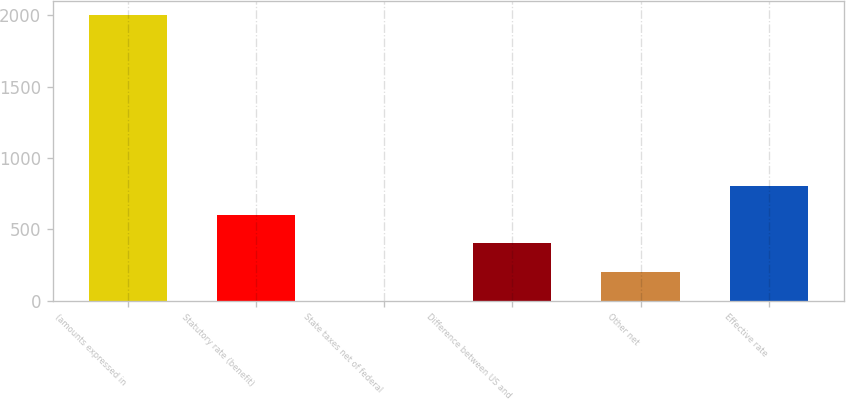Convert chart. <chart><loc_0><loc_0><loc_500><loc_500><bar_chart><fcel>(amounts expressed in<fcel>Statutory rate (benefit)<fcel>State taxes net of federal<fcel>Difference between US and<fcel>Other net<fcel>Effective rate<nl><fcel>2002<fcel>601.37<fcel>1.1<fcel>401.28<fcel>201.19<fcel>801.46<nl></chart> 